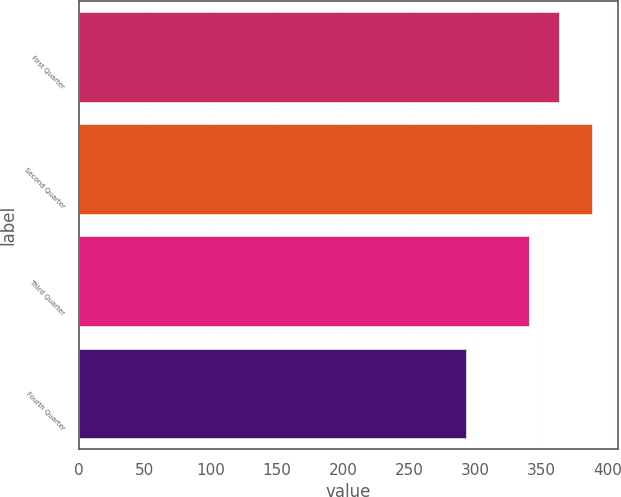Convert chart. <chart><loc_0><loc_0><loc_500><loc_500><bar_chart><fcel>First Quarter<fcel>Second Quarter<fcel>Third Quarter<fcel>Fourth Quarter<nl><fcel>362.8<fcel>388.01<fcel>340.51<fcel>292.89<nl></chart> 